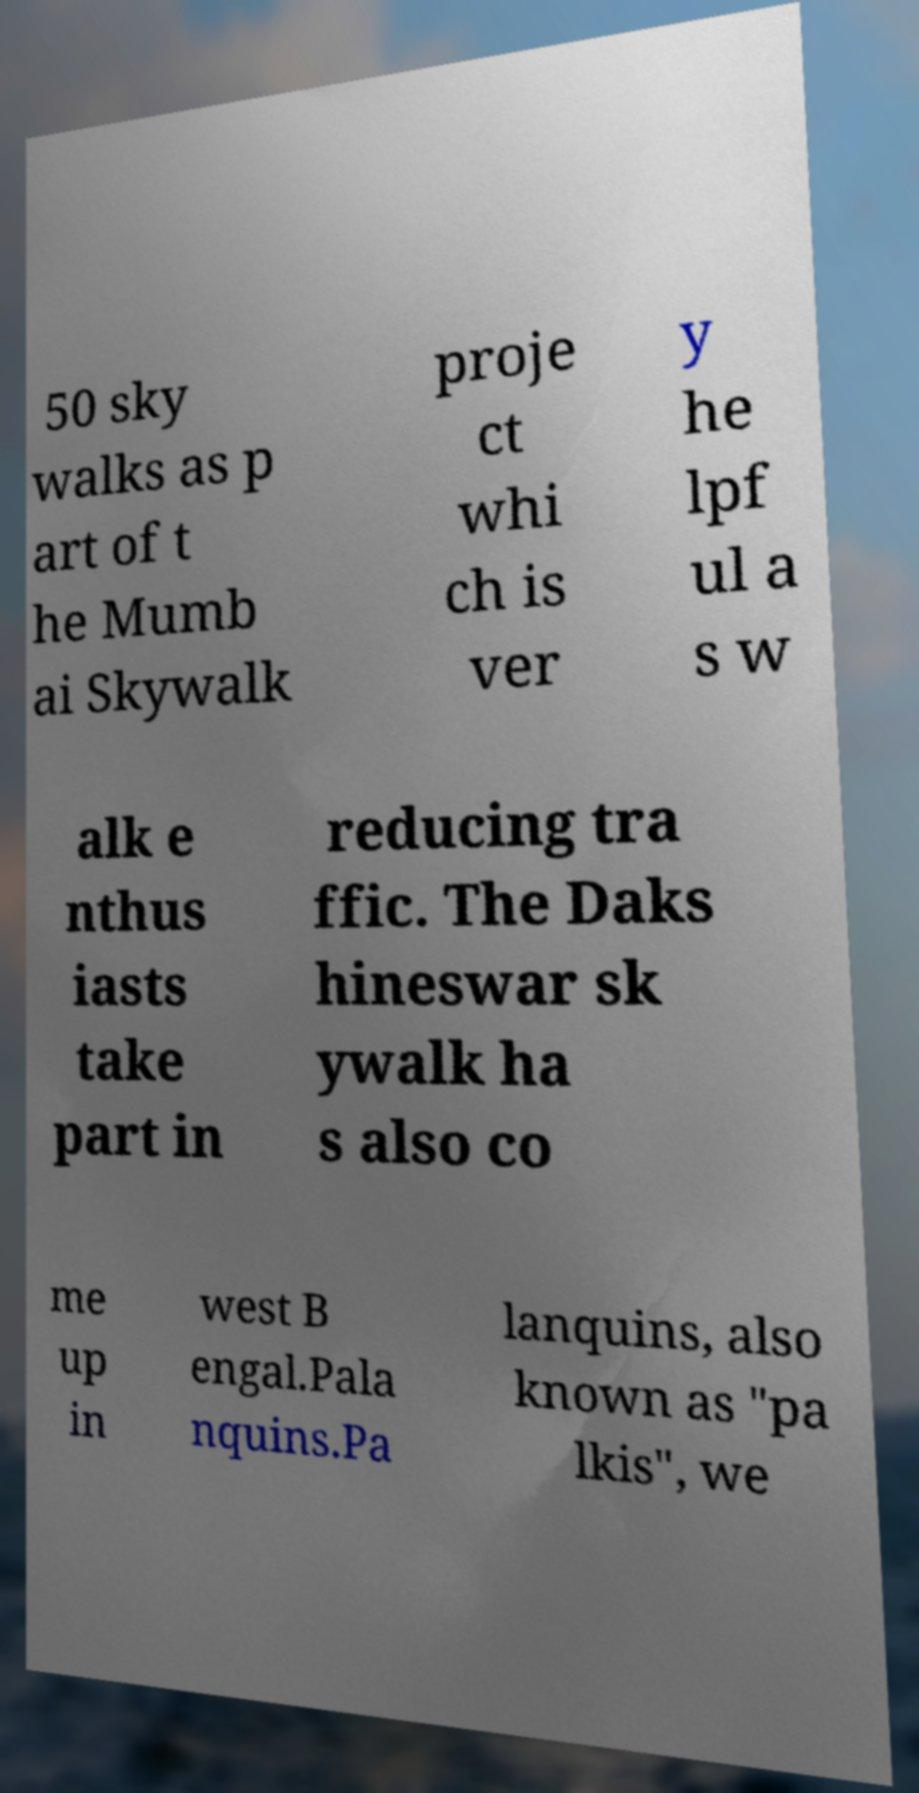There's text embedded in this image that I need extracted. Can you transcribe it verbatim? 50 sky walks as p art of t he Mumb ai Skywalk proje ct whi ch is ver y he lpf ul a s w alk e nthus iasts take part in reducing tra ffic. The Daks hineswar sk ywalk ha s also co me up in west B engal.Pala nquins.Pa lanquins, also known as "pa lkis", we 